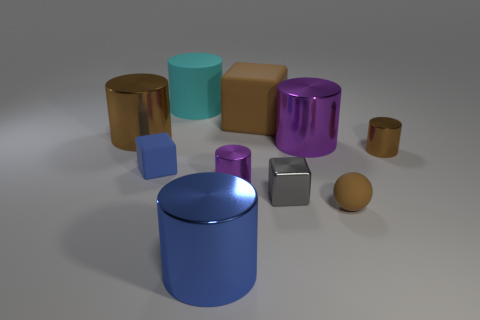Subtract 2 cylinders. How many cylinders are left? 4 Subtract all purple cylinders. How many cylinders are left? 4 Subtract all big blue cylinders. How many cylinders are left? 5 Subtract all cyan cylinders. Subtract all blue spheres. How many cylinders are left? 5 Subtract all blocks. How many objects are left? 7 Add 5 brown spheres. How many brown spheres are left? 6 Add 3 small gray shiny blocks. How many small gray shiny blocks exist? 4 Subtract 2 purple cylinders. How many objects are left? 8 Subtract all blue cubes. Subtract all small brown rubber things. How many objects are left? 8 